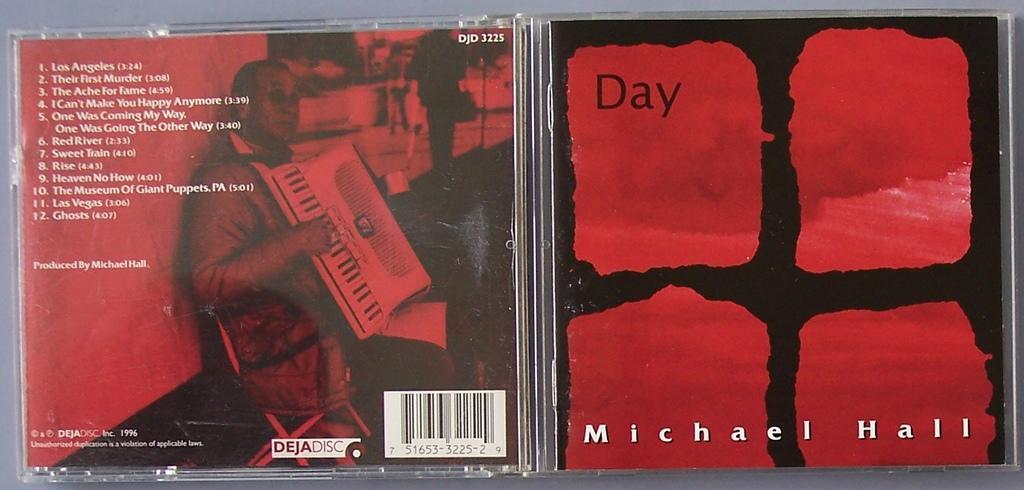Please provide a concise description of this image. In this image there is a disc cover kept on the floor. There is some text on it. Left side there is a person holding a musical instrument. 